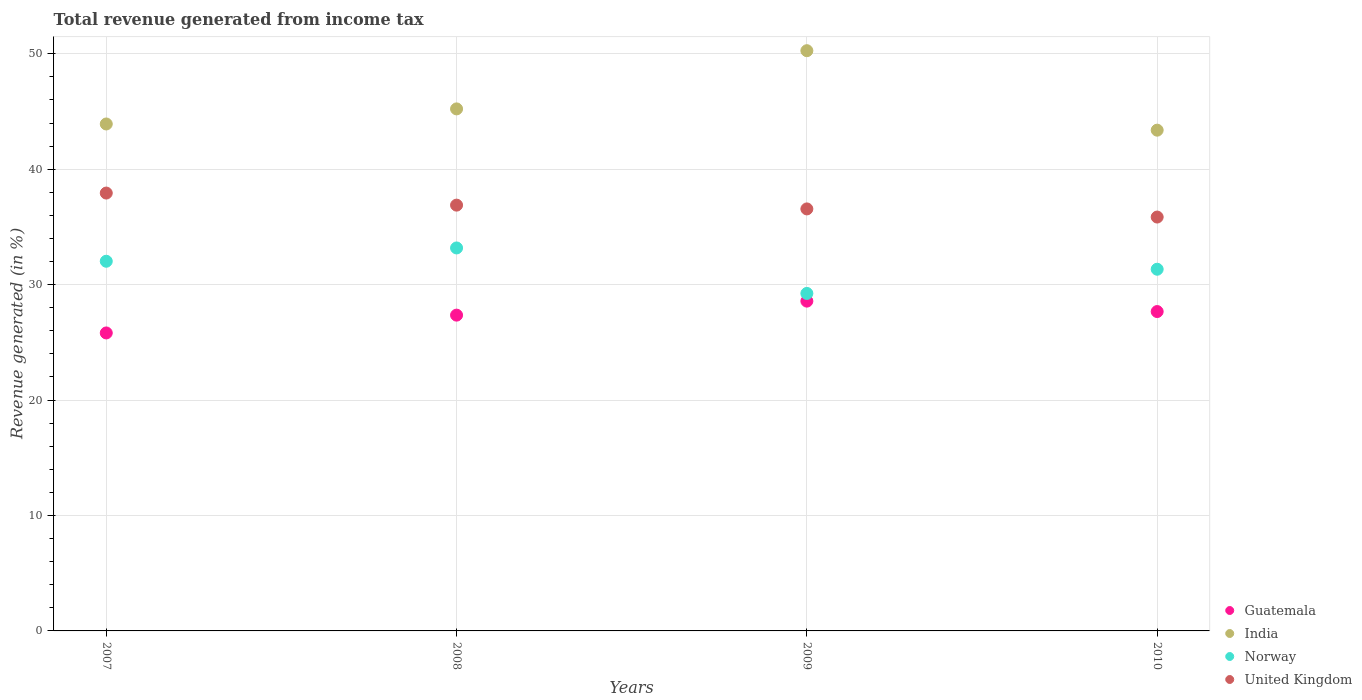What is the total revenue generated in Norway in 2010?
Your answer should be compact. 31.34. Across all years, what is the maximum total revenue generated in India?
Keep it short and to the point. 50.27. Across all years, what is the minimum total revenue generated in United Kingdom?
Offer a very short reply. 35.86. In which year was the total revenue generated in Guatemala maximum?
Provide a short and direct response. 2009. In which year was the total revenue generated in Guatemala minimum?
Your answer should be very brief. 2007. What is the total total revenue generated in Guatemala in the graph?
Make the answer very short. 109.42. What is the difference between the total revenue generated in Norway in 2008 and that in 2009?
Offer a very short reply. 3.94. What is the difference between the total revenue generated in Guatemala in 2007 and the total revenue generated in United Kingdom in 2008?
Keep it short and to the point. -11.07. What is the average total revenue generated in United Kingdom per year?
Ensure brevity in your answer.  36.81. In the year 2008, what is the difference between the total revenue generated in United Kingdom and total revenue generated in India?
Offer a very short reply. -8.34. In how many years, is the total revenue generated in Norway greater than 24 %?
Your answer should be compact. 4. What is the ratio of the total revenue generated in Norway in 2007 to that in 2010?
Provide a short and direct response. 1.02. Is the total revenue generated in Guatemala in 2007 less than that in 2010?
Make the answer very short. Yes. What is the difference between the highest and the second highest total revenue generated in India?
Offer a terse response. 5.04. What is the difference between the highest and the lowest total revenue generated in United Kingdom?
Provide a short and direct response. 2.08. Is the sum of the total revenue generated in United Kingdom in 2007 and 2009 greater than the maximum total revenue generated in Norway across all years?
Your answer should be compact. Yes. Is it the case that in every year, the sum of the total revenue generated in Guatemala and total revenue generated in India  is greater than the sum of total revenue generated in United Kingdom and total revenue generated in Norway?
Keep it short and to the point. No. Does the total revenue generated in United Kingdom monotonically increase over the years?
Offer a very short reply. No. Is the total revenue generated in Guatemala strictly greater than the total revenue generated in India over the years?
Offer a very short reply. No. Is the total revenue generated in United Kingdom strictly less than the total revenue generated in India over the years?
Your answer should be very brief. Yes. How many dotlines are there?
Keep it short and to the point. 4. How many years are there in the graph?
Provide a succinct answer. 4. What is the difference between two consecutive major ticks on the Y-axis?
Your answer should be compact. 10. Are the values on the major ticks of Y-axis written in scientific E-notation?
Provide a short and direct response. No. Does the graph contain any zero values?
Your answer should be compact. No. How many legend labels are there?
Make the answer very short. 4. How are the legend labels stacked?
Offer a terse response. Vertical. What is the title of the graph?
Your response must be concise. Total revenue generated from income tax. What is the label or title of the Y-axis?
Your answer should be compact. Revenue generated (in %). What is the Revenue generated (in %) in Guatemala in 2007?
Make the answer very short. 25.82. What is the Revenue generated (in %) in India in 2007?
Your answer should be compact. 43.92. What is the Revenue generated (in %) in Norway in 2007?
Keep it short and to the point. 32.03. What is the Revenue generated (in %) of United Kingdom in 2007?
Offer a very short reply. 37.94. What is the Revenue generated (in %) in Guatemala in 2008?
Your response must be concise. 27.36. What is the Revenue generated (in %) of India in 2008?
Your answer should be compact. 45.23. What is the Revenue generated (in %) in Norway in 2008?
Make the answer very short. 33.18. What is the Revenue generated (in %) of United Kingdom in 2008?
Offer a very short reply. 36.89. What is the Revenue generated (in %) in Guatemala in 2009?
Offer a very short reply. 28.57. What is the Revenue generated (in %) of India in 2009?
Provide a short and direct response. 50.27. What is the Revenue generated (in %) of Norway in 2009?
Keep it short and to the point. 29.24. What is the Revenue generated (in %) in United Kingdom in 2009?
Your answer should be very brief. 36.56. What is the Revenue generated (in %) in Guatemala in 2010?
Make the answer very short. 27.67. What is the Revenue generated (in %) of India in 2010?
Your answer should be very brief. 43.38. What is the Revenue generated (in %) in Norway in 2010?
Provide a short and direct response. 31.34. What is the Revenue generated (in %) of United Kingdom in 2010?
Your answer should be very brief. 35.86. Across all years, what is the maximum Revenue generated (in %) in Guatemala?
Provide a succinct answer. 28.57. Across all years, what is the maximum Revenue generated (in %) in India?
Provide a short and direct response. 50.27. Across all years, what is the maximum Revenue generated (in %) in Norway?
Ensure brevity in your answer.  33.18. Across all years, what is the maximum Revenue generated (in %) in United Kingdom?
Provide a succinct answer. 37.94. Across all years, what is the minimum Revenue generated (in %) in Guatemala?
Your answer should be compact. 25.82. Across all years, what is the minimum Revenue generated (in %) of India?
Keep it short and to the point. 43.38. Across all years, what is the minimum Revenue generated (in %) in Norway?
Ensure brevity in your answer.  29.24. Across all years, what is the minimum Revenue generated (in %) of United Kingdom?
Offer a terse response. 35.86. What is the total Revenue generated (in %) of Guatemala in the graph?
Offer a terse response. 109.42. What is the total Revenue generated (in %) of India in the graph?
Offer a very short reply. 182.81. What is the total Revenue generated (in %) of Norway in the graph?
Provide a succinct answer. 125.78. What is the total Revenue generated (in %) of United Kingdom in the graph?
Keep it short and to the point. 147.25. What is the difference between the Revenue generated (in %) in Guatemala in 2007 and that in 2008?
Ensure brevity in your answer.  -1.54. What is the difference between the Revenue generated (in %) in India in 2007 and that in 2008?
Ensure brevity in your answer.  -1.31. What is the difference between the Revenue generated (in %) of Norway in 2007 and that in 2008?
Keep it short and to the point. -1.15. What is the difference between the Revenue generated (in %) of United Kingdom in 2007 and that in 2008?
Ensure brevity in your answer.  1.05. What is the difference between the Revenue generated (in %) in Guatemala in 2007 and that in 2009?
Provide a succinct answer. -2.76. What is the difference between the Revenue generated (in %) of India in 2007 and that in 2009?
Ensure brevity in your answer.  -6.35. What is the difference between the Revenue generated (in %) of Norway in 2007 and that in 2009?
Keep it short and to the point. 2.79. What is the difference between the Revenue generated (in %) in United Kingdom in 2007 and that in 2009?
Offer a terse response. 1.37. What is the difference between the Revenue generated (in %) in Guatemala in 2007 and that in 2010?
Give a very brief answer. -1.85. What is the difference between the Revenue generated (in %) in India in 2007 and that in 2010?
Your answer should be very brief. 0.54. What is the difference between the Revenue generated (in %) of Norway in 2007 and that in 2010?
Provide a short and direct response. 0.69. What is the difference between the Revenue generated (in %) of United Kingdom in 2007 and that in 2010?
Offer a terse response. 2.08. What is the difference between the Revenue generated (in %) in Guatemala in 2008 and that in 2009?
Offer a terse response. -1.21. What is the difference between the Revenue generated (in %) in India in 2008 and that in 2009?
Offer a very short reply. -5.04. What is the difference between the Revenue generated (in %) of Norway in 2008 and that in 2009?
Provide a short and direct response. 3.94. What is the difference between the Revenue generated (in %) of United Kingdom in 2008 and that in 2009?
Your answer should be very brief. 0.33. What is the difference between the Revenue generated (in %) in Guatemala in 2008 and that in 2010?
Provide a succinct answer. -0.31. What is the difference between the Revenue generated (in %) of India in 2008 and that in 2010?
Your answer should be very brief. 1.84. What is the difference between the Revenue generated (in %) of Norway in 2008 and that in 2010?
Your answer should be compact. 1.84. What is the difference between the Revenue generated (in %) in United Kingdom in 2008 and that in 2010?
Your response must be concise. 1.03. What is the difference between the Revenue generated (in %) in Guatemala in 2009 and that in 2010?
Keep it short and to the point. 0.9. What is the difference between the Revenue generated (in %) in India in 2009 and that in 2010?
Offer a terse response. 6.89. What is the difference between the Revenue generated (in %) in Norway in 2009 and that in 2010?
Your answer should be very brief. -2.1. What is the difference between the Revenue generated (in %) of United Kingdom in 2009 and that in 2010?
Offer a very short reply. 0.7. What is the difference between the Revenue generated (in %) of Guatemala in 2007 and the Revenue generated (in %) of India in 2008?
Provide a short and direct response. -19.41. What is the difference between the Revenue generated (in %) of Guatemala in 2007 and the Revenue generated (in %) of Norway in 2008?
Provide a short and direct response. -7.36. What is the difference between the Revenue generated (in %) in Guatemala in 2007 and the Revenue generated (in %) in United Kingdom in 2008?
Offer a very short reply. -11.07. What is the difference between the Revenue generated (in %) of India in 2007 and the Revenue generated (in %) of Norway in 2008?
Offer a very short reply. 10.74. What is the difference between the Revenue generated (in %) in India in 2007 and the Revenue generated (in %) in United Kingdom in 2008?
Your answer should be very brief. 7.03. What is the difference between the Revenue generated (in %) of Norway in 2007 and the Revenue generated (in %) of United Kingdom in 2008?
Ensure brevity in your answer.  -4.86. What is the difference between the Revenue generated (in %) of Guatemala in 2007 and the Revenue generated (in %) of India in 2009?
Your response must be concise. -24.45. What is the difference between the Revenue generated (in %) of Guatemala in 2007 and the Revenue generated (in %) of Norway in 2009?
Your answer should be compact. -3.42. What is the difference between the Revenue generated (in %) of Guatemala in 2007 and the Revenue generated (in %) of United Kingdom in 2009?
Your response must be concise. -10.75. What is the difference between the Revenue generated (in %) in India in 2007 and the Revenue generated (in %) in Norway in 2009?
Make the answer very short. 14.68. What is the difference between the Revenue generated (in %) in India in 2007 and the Revenue generated (in %) in United Kingdom in 2009?
Give a very brief answer. 7.36. What is the difference between the Revenue generated (in %) in Norway in 2007 and the Revenue generated (in %) in United Kingdom in 2009?
Offer a terse response. -4.53. What is the difference between the Revenue generated (in %) of Guatemala in 2007 and the Revenue generated (in %) of India in 2010?
Offer a very short reply. -17.57. What is the difference between the Revenue generated (in %) of Guatemala in 2007 and the Revenue generated (in %) of Norway in 2010?
Your response must be concise. -5.52. What is the difference between the Revenue generated (in %) of Guatemala in 2007 and the Revenue generated (in %) of United Kingdom in 2010?
Your answer should be compact. -10.04. What is the difference between the Revenue generated (in %) in India in 2007 and the Revenue generated (in %) in Norway in 2010?
Keep it short and to the point. 12.58. What is the difference between the Revenue generated (in %) of India in 2007 and the Revenue generated (in %) of United Kingdom in 2010?
Your response must be concise. 8.06. What is the difference between the Revenue generated (in %) in Norway in 2007 and the Revenue generated (in %) in United Kingdom in 2010?
Give a very brief answer. -3.83. What is the difference between the Revenue generated (in %) of Guatemala in 2008 and the Revenue generated (in %) of India in 2009?
Provide a short and direct response. -22.91. What is the difference between the Revenue generated (in %) in Guatemala in 2008 and the Revenue generated (in %) in Norway in 2009?
Keep it short and to the point. -1.88. What is the difference between the Revenue generated (in %) of Guatemala in 2008 and the Revenue generated (in %) of United Kingdom in 2009?
Offer a terse response. -9.2. What is the difference between the Revenue generated (in %) in India in 2008 and the Revenue generated (in %) in Norway in 2009?
Ensure brevity in your answer.  15.99. What is the difference between the Revenue generated (in %) of India in 2008 and the Revenue generated (in %) of United Kingdom in 2009?
Give a very brief answer. 8.67. What is the difference between the Revenue generated (in %) of Norway in 2008 and the Revenue generated (in %) of United Kingdom in 2009?
Offer a terse response. -3.38. What is the difference between the Revenue generated (in %) of Guatemala in 2008 and the Revenue generated (in %) of India in 2010?
Ensure brevity in your answer.  -16.03. What is the difference between the Revenue generated (in %) of Guatemala in 2008 and the Revenue generated (in %) of Norway in 2010?
Make the answer very short. -3.98. What is the difference between the Revenue generated (in %) of Guatemala in 2008 and the Revenue generated (in %) of United Kingdom in 2010?
Make the answer very short. -8.5. What is the difference between the Revenue generated (in %) in India in 2008 and the Revenue generated (in %) in Norway in 2010?
Your response must be concise. 13.89. What is the difference between the Revenue generated (in %) of India in 2008 and the Revenue generated (in %) of United Kingdom in 2010?
Give a very brief answer. 9.37. What is the difference between the Revenue generated (in %) of Norway in 2008 and the Revenue generated (in %) of United Kingdom in 2010?
Provide a short and direct response. -2.68. What is the difference between the Revenue generated (in %) in Guatemala in 2009 and the Revenue generated (in %) in India in 2010?
Your answer should be compact. -14.81. What is the difference between the Revenue generated (in %) in Guatemala in 2009 and the Revenue generated (in %) in Norway in 2010?
Offer a terse response. -2.76. What is the difference between the Revenue generated (in %) in Guatemala in 2009 and the Revenue generated (in %) in United Kingdom in 2010?
Make the answer very short. -7.28. What is the difference between the Revenue generated (in %) of India in 2009 and the Revenue generated (in %) of Norway in 2010?
Your response must be concise. 18.93. What is the difference between the Revenue generated (in %) in India in 2009 and the Revenue generated (in %) in United Kingdom in 2010?
Your answer should be compact. 14.41. What is the difference between the Revenue generated (in %) in Norway in 2009 and the Revenue generated (in %) in United Kingdom in 2010?
Offer a very short reply. -6.62. What is the average Revenue generated (in %) of Guatemala per year?
Keep it short and to the point. 27.35. What is the average Revenue generated (in %) in India per year?
Keep it short and to the point. 45.7. What is the average Revenue generated (in %) of Norway per year?
Your response must be concise. 31.45. What is the average Revenue generated (in %) of United Kingdom per year?
Your answer should be very brief. 36.81. In the year 2007, what is the difference between the Revenue generated (in %) of Guatemala and Revenue generated (in %) of India?
Your answer should be very brief. -18.11. In the year 2007, what is the difference between the Revenue generated (in %) of Guatemala and Revenue generated (in %) of Norway?
Your answer should be very brief. -6.21. In the year 2007, what is the difference between the Revenue generated (in %) in Guatemala and Revenue generated (in %) in United Kingdom?
Offer a very short reply. -12.12. In the year 2007, what is the difference between the Revenue generated (in %) in India and Revenue generated (in %) in Norway?
Make the answer very short. 11.89. In the year 2007, what is the difference between the Revenue generated (in %) in India and Revenue generated (in %) in United Kingdom?
Provide a short and direct response. 5.98. In the year 2007, what is the difference between the Revenue generated (in %) of Norway and Revenue generated (in %) of United Kingdom?
Your response must be concise. -5.91. In the year 2008, what is the difference between the Revenue generated (in %) of Guatemala and Revenue generated (in %) of India?
Give a very brief answer. -17.87. In the year 2008, what is the difference between the Revenue generated (in %) of Guatemala and Revenue generated (in %) of Norway?
Make the answer very short. -5.82. In the year 2008, what is the difference between the Revenue generated (in %) in Guatemala and Revenue generated (in %) in United Kingdom?
Offer a very short reply. -9.53. In the year 2008, what is the difference between the Revenue generated (in %) in India and Revenue generated (in %) in Norway?
Your answer should be compact. 12.05. In the year 2008, what is the difference between the Revenue generated (in %) of India and Revenue generated (in %) of United Kingdom?
Give a very brief answer. 8.34. In the year 2008, what is the difference between the Revenue generated (in %) of Norway and Revenue generated (in %) of United Kingdom?
Provide a short and direct response. -3.71. In the year 2009, what is the difference between the Revenue generated (in %) in Guatemala and Revenue generated (in %) in India?
Offer a very short reply. -21.7. In the year 2009, what is the difference between the Revenue generated (in %) of Guatemala and Revenue generated (in %) of Norway?
Your response must be concise. -0.67. In the year 2009, what is the difference between the Revenue generated (in %) of Guatemala and Revenue generated (in %) of United Kingdom?
Offer a terse response. -7.99. In the year 2009, what is the difference between the Revenue generated (in %) of India and Revenue generated (in %) of Norway?
Offer a terse response. 21.03. In the year 2009, what is the difference between the Revenue generated (in %) of India and Revenue generated (in %) of United Kingdom?
Offer a terse response. 13.71. In the year 2009, what is the difference between the Revenue generated (in %) of Norway and Revenue generated (in %) of United Kingdom?
Your answer should be very brief. -7.32. In the year 2010, what is the difference between the Revenue generated (in %) of Guatemala and Revenue generated (in %) of India?
Your response must be concise. -15.71. In the year 2010, what is the difference between the Revenue generated (in %) of Guatemala and Revenue generated (in %) of Norway?
Give a very brief answer. -3.67. In the year 2010, what is the difference between the Revenue generated (in %) in Guatemala and Revenue generated (in %) in United Kingdom?
Offer a terse response. -8.19. In the year 2010, what is the difference between the Revenue generated (in %) in India and Revenue generated (in %) in Norway?
Make the answer very short. 12.05. In the year 2010, what is the difference between the Revenue generated (in %) of India and Revenue generated (in %) of United Kingdom?
Give a very brief answer. 7.53. In the year 2010, what is the difference between the Revenue generated (in %) of Norway and Revenue generated (in %) of United Kingdom?
Give a very brief answer. -4.52. What is the ratio of the Revenue generated (in %) in Guatemala in 2007 to that in 2008?
Ensure brevity in your answer.  0.94. What is the ratio of the Revenue generated (in %) of India in 2007 to that in 2008?
Provide a succinct answer. 0.97. What is the ratio of the Revenue generated (in %) of Norway in 2007 to that in 2008?
Your response must be concise. 0.97. What is the ratio of the Revenue generated (in %) of United Kingdom in 2007 to that in 2008?
Make the answer very short. 1.03. What is the ratio of the Revenue generated (in %) in Guatemala in 2007 to that in 2009?
Offer a terse response. 0.9. What is the ratio of the Revenue generated (in %) of India in 2007 to that in 2009?
Your answer should be compact. 0.87. What is the ratio of the Revenue generated (in %) in Norway in 2007 to that in 2009?
Provide a short and direct response. 1.1. What is the ratio of the Revenue generated (in %) in United Kingdom in 2007 to that in 2009?
Your answer should be very brief. 1.04. What is the ratio of the Revenue generated (in %) in Guatemala in 2007 to that in 2010?
Offer a very short reply. 0.93. What is the ratio of the Revenue generated (in %) of India in 2007 to that in 2010?
Provide a short and direct response. 1.01. What is the ratio of the Revenue generated (in %) of Norway in 2007 to that in 2010?
Your answer should be compact. 1.02. What is the ratio of the Revenue generated (in %) in United Kingdom in 2007 to that in 2010?
Provide a succinct answer. 1.06. What is the ratio of the Revenue generated (in %) in Guatemala in 2008 to that in 2009?
Your answer should be very brief. 0.96. What is the ratio of the Revenue generated (in %) in India in 2008 to that in 2009?
Offer a terse response. 0.9. What is the ratio of the Revenue generated (in %) of Norway in 2008 to that in 2009?
Your response must be concise. 1.13. What is the ratio of the Revenue generated (in %) of United Kingdom in 2008 to that in 2009?
Your answer should be compact. 1.01. What is the ratio of the Revenue generated (in %) in Guatemala in 2008 to that in 2010?
Provide a succinct answer. 0.99. What is the ratio of the Revenue generated (in %) in India in 2008 to that in 2010?
Your answer should be very brief. 1.04. What is the ratio of the Revenue generated (in %) in Norway in 2008 to that in 2010?
Keep it short and to the point. 1.06. What is the ratio of the Revenue generated (in %) in United Kingdom in 2008 to that in 2010?
Your answer should be very brief. 1.03. What is the ratio of the Revenue generated (in %) of Guatemala in 2009 to that in 2010?
Offer a very short reply. 1.03. What is the ratio of the Revenue generated (in %) in India in 2009 to that in 2010?
Your answer should be very brief. 1.16. What is the ratio of the Revenue generated (in %) in Norway in 2009 to that in 2010?
Your answer should be very brief. 0.93. What is the ratio of the Revenue generated (in %) in United Kingdom in 2009 to that in 2010?
Offer a very short reply. 1.02. What is the difference between the highest and the second highest Revenue generated (in %) of Guatemala?
Make the answer very short. 0.9. What is the difference between the highest and the second highest Revenue generated (in %) in India?
Your answer should be very brief. 5.04. What is the difference between the highest and the second highest Revenue generated (in %) in Norway?
Your answer should be very brief. 1.15. What is the difference between the highest and the second highest Revenue generated (in %) of United Kingdom?
Offer a terse response. 1.05. What is the difference between the highest and the lowest Revenue generated (in %) in Guatemala?
Provide a short and direct response. 2.76. What is the difference between the highest and the lowest Revenue generated (in %) in India?
Offer a terse response. 6.89. What is the difference between the highest and the lowest Revenue generated (in %) in Norway?
Offer a very short reply. 3.94. What is the difference between the highest and the lowest Revenue generated (in %) in United Kingdom?
Make the answer very short. 2.08. 